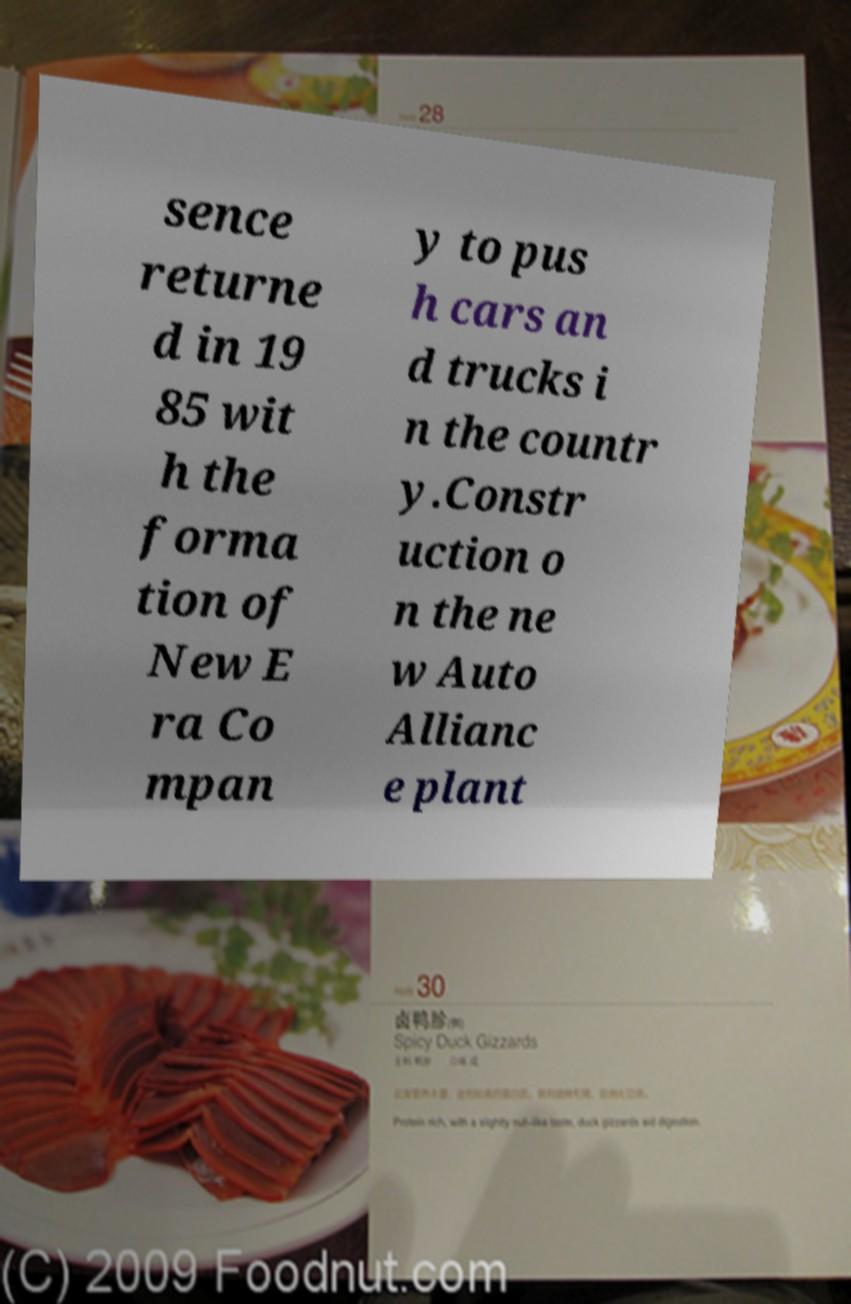For documentation purposes, I need the text within this image transcribed. Could you provide that? sence returne d in 19 85 wit h the forma tion of New E ra Co mpan y to pus h cars an d trucks i n the countr y.Constr uction o n the ne w Auto Allianc e plant 